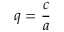<formula> <loc_0><loc_0><loc_500><loc_500>q = { \frac { c } { a } }</formula> 